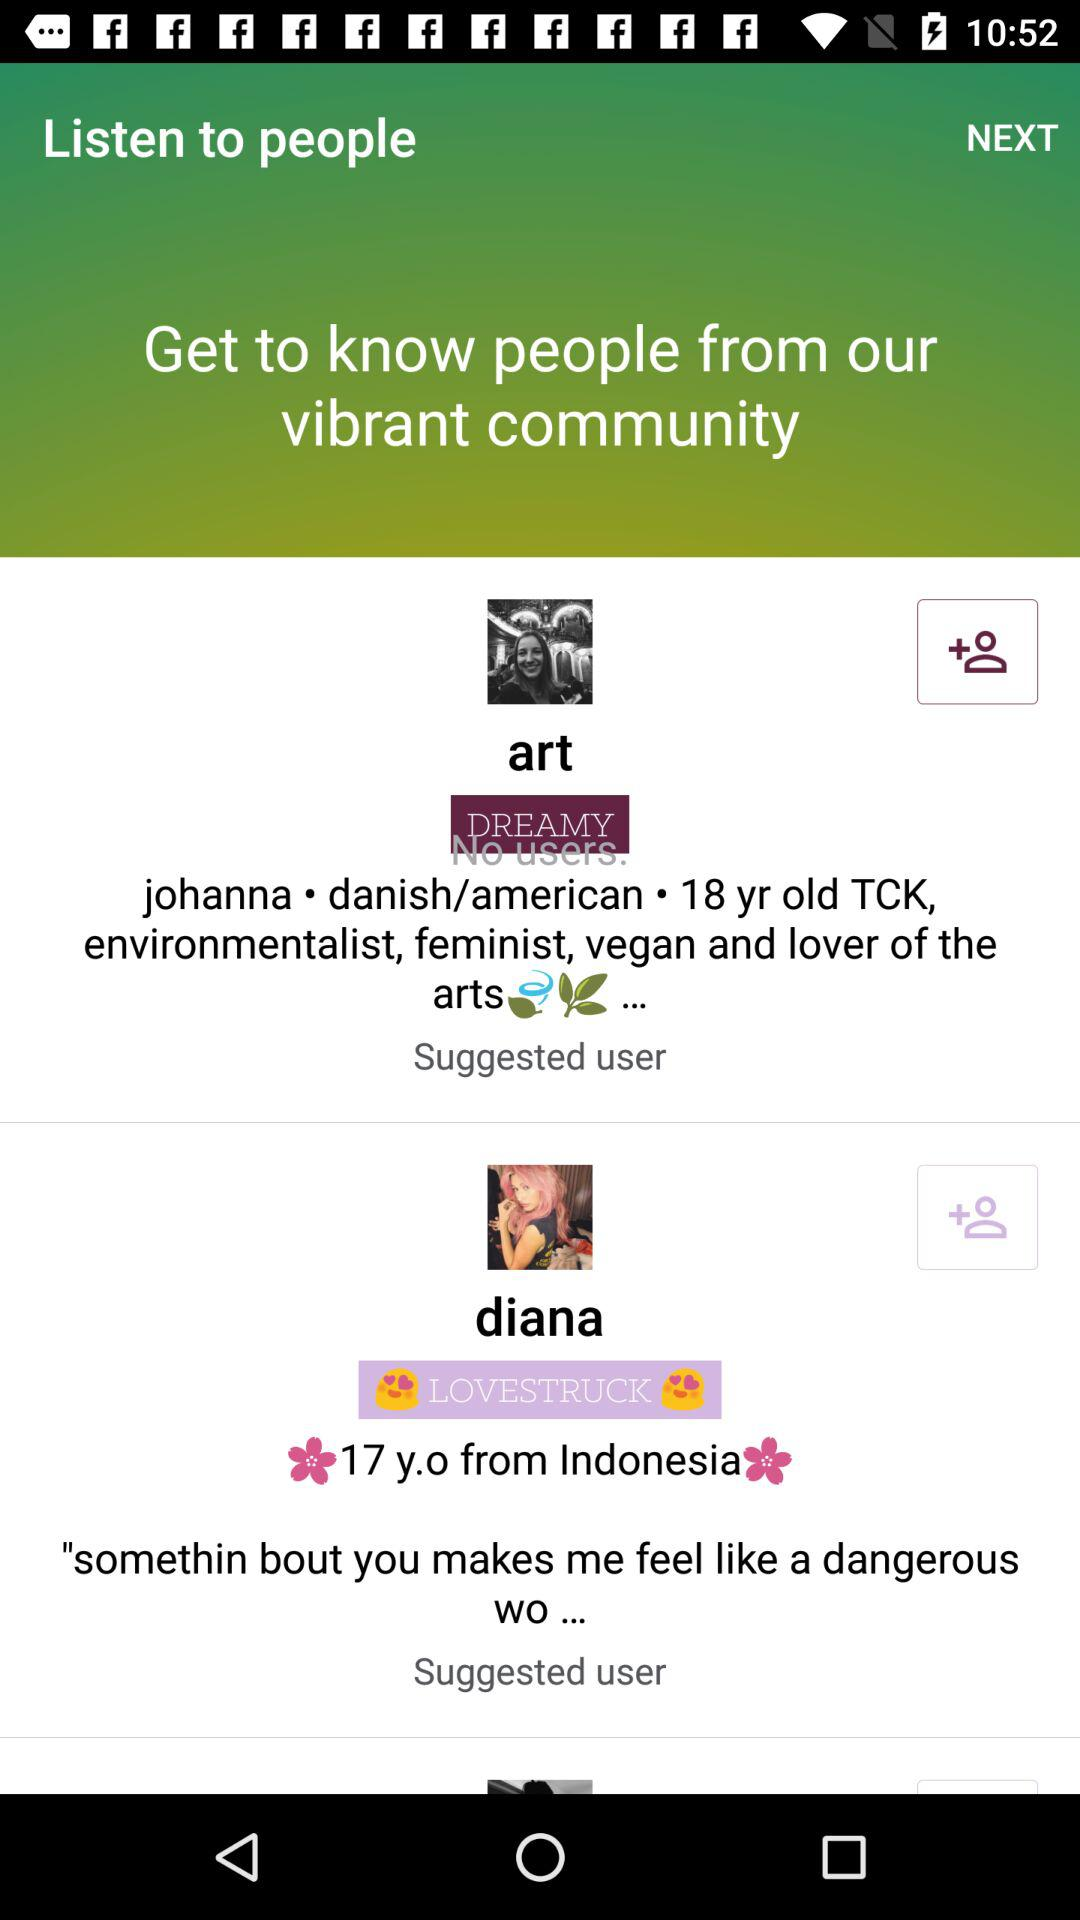Johanna belongs to which country?
When the provided information is insufficient, respond with <no answer>. <no answer> 